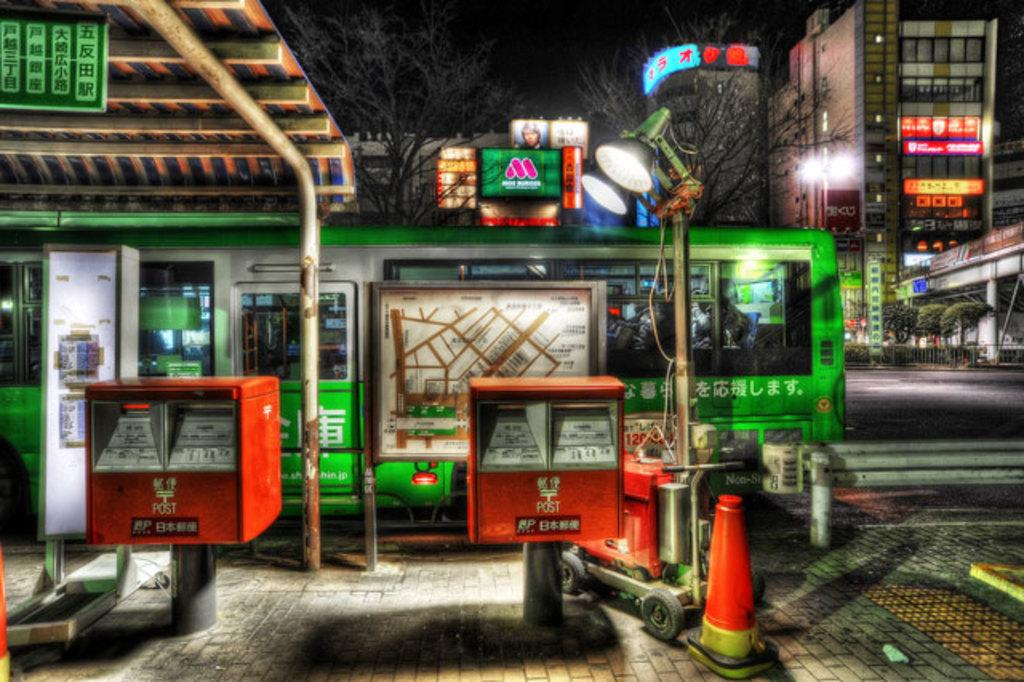<image>
Summarize the visual content of the image. Two orange Post containers stand outside a green building. 